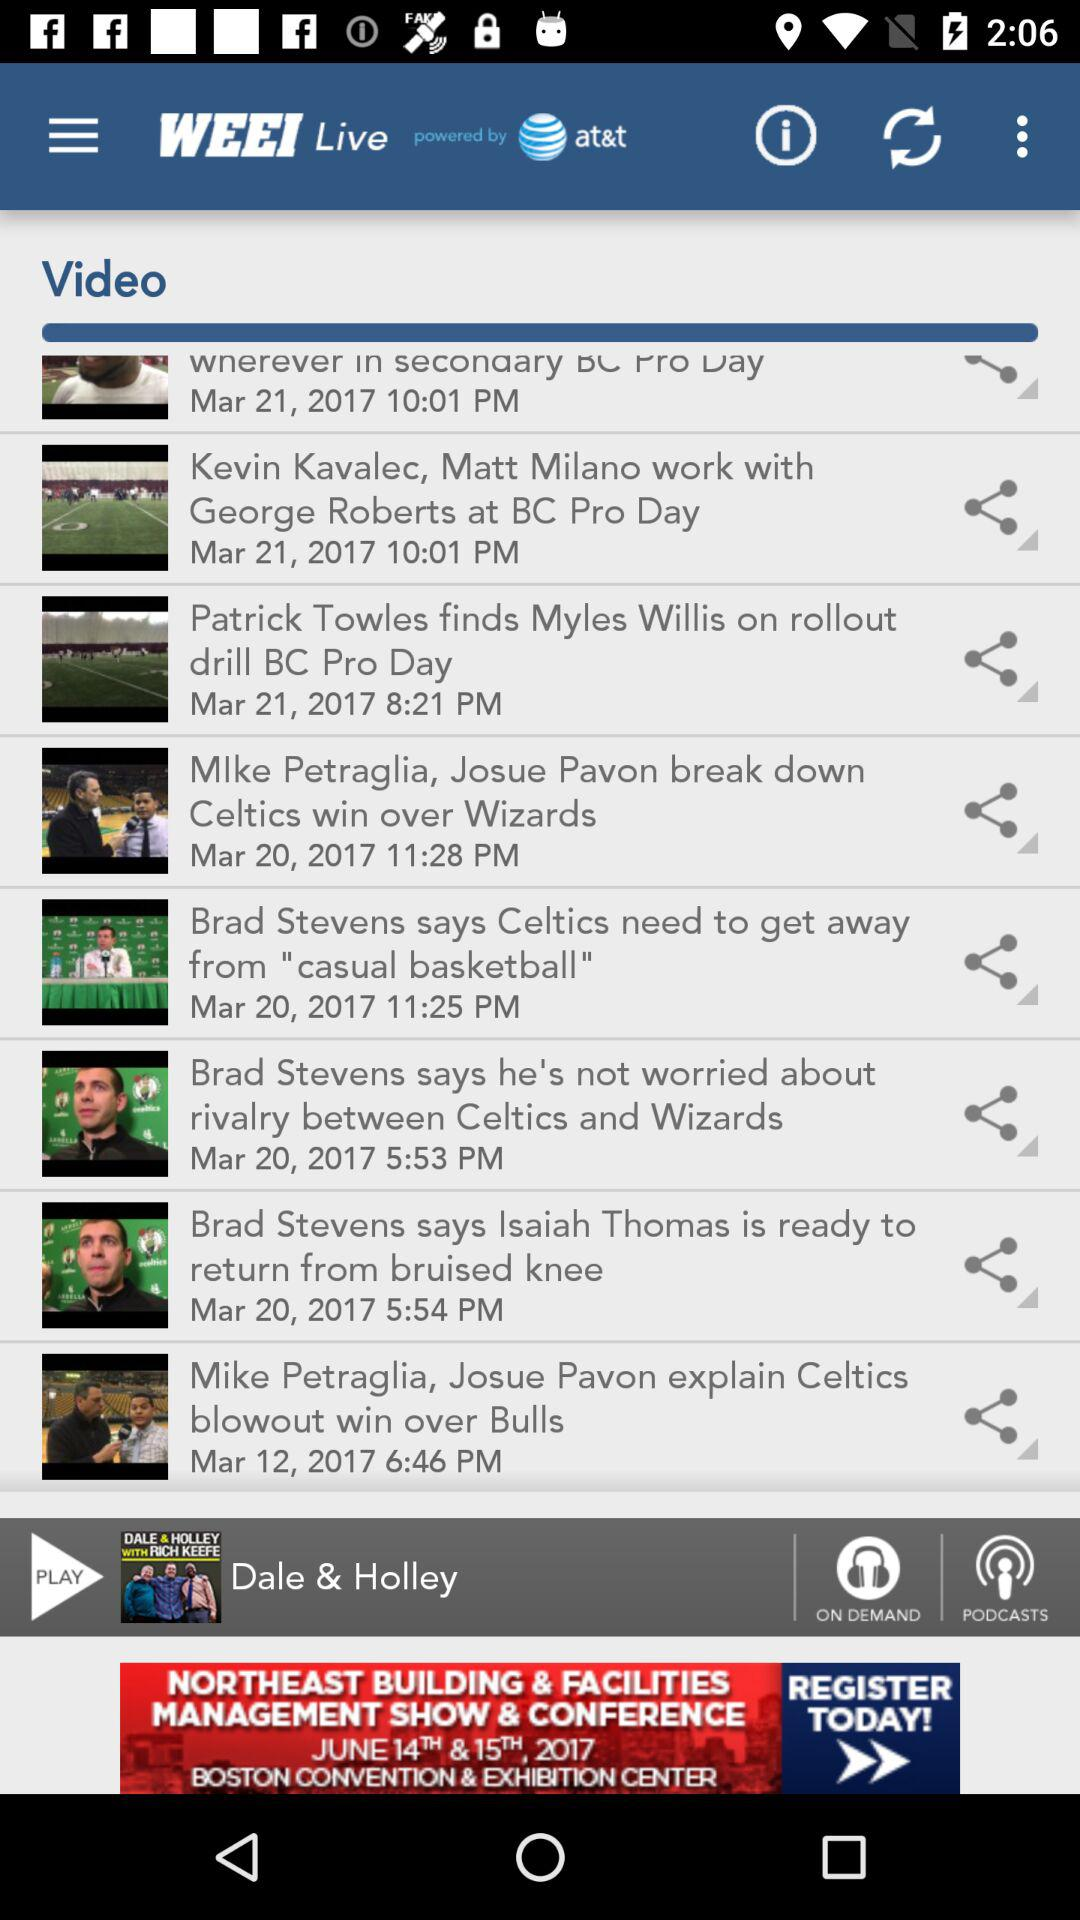What is the posted date of the video "Patrick Towles finds Myles Willis on rollout drill BC Pro Day"? The posted date is March 21, 2017. 